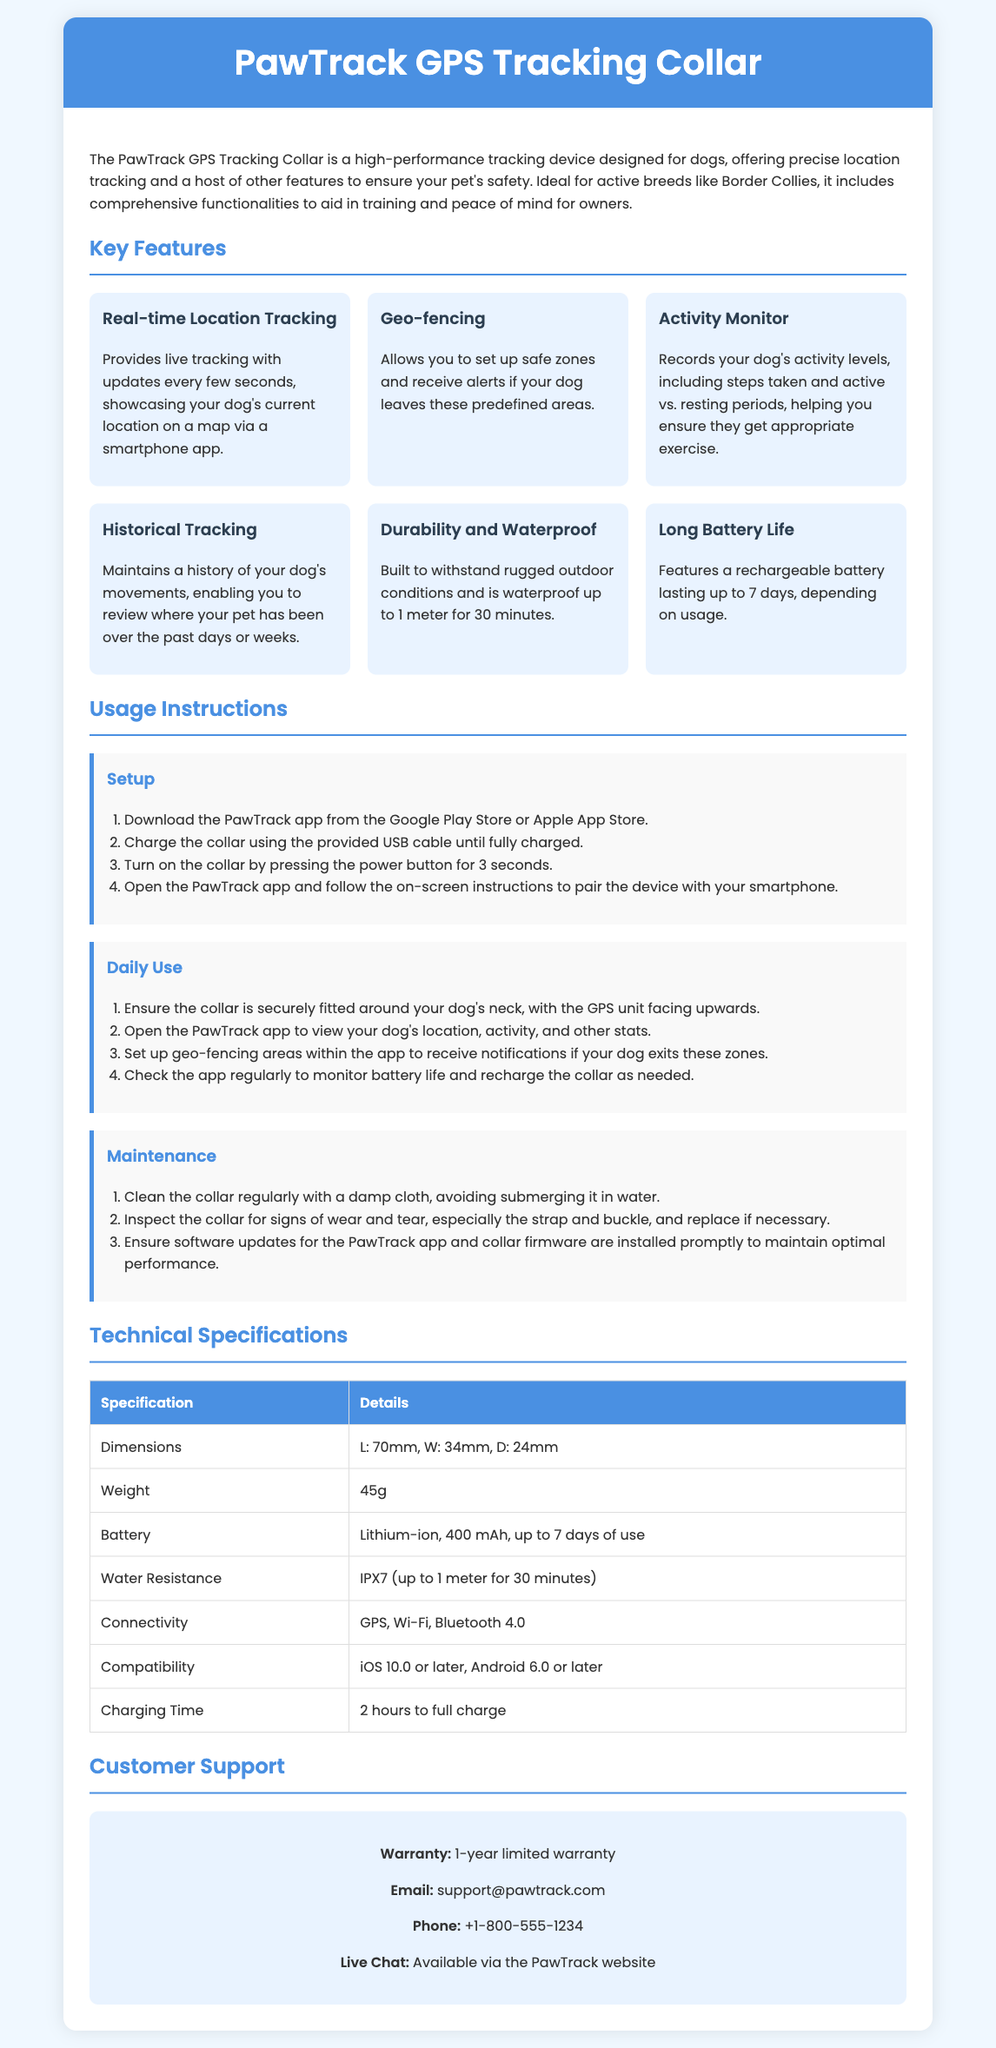What is the name of the product? The name of the product is highlighted in the header section of the document.
Answer: PawTrack GPS Tracking Collar What feature allows you to set up safe zones? This feature is described in the "Key Features" section, specifically relating to safety for dogs.
Answer: Geo-fencing What is the maximum battery life of the collar? The battery duration is specified under "Key Features."
Answer: Up to 7 days What is the weight of the device? The weight is listed in the "Technical Specifications" table.
Answer: 45g How long does it take to fully charge the collar? The charging duration is mentioned in the "Technical Specifications" section.
Answer: 2 hours What is the water resistance rating? The water resistance information is presented in the "Technical Specifications" table.
Answer: IPX7 Which operating systems are compatible with the collar? Compatibility details are provided in the "Technical Specifications" section, enumerating the supported operating systems.
Answer: iOS 10.0 or later, Android 6.0 or later What should be done to ensure the collar is securely fitted? This instruction is given in the "Daily Use" section for proper collar setup.
Answer: Ensure the collar is securely fitted around your dog's neck Where can customers reach out for support? Support contact details are provided in the "Customer Support" section.
Answer: support@pawtrack.com 